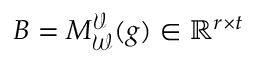<formula> <loc_0><loc_0><loc_500><loc_500>B = M _ { \mathcal { W } } ^ { \mathcal { V } } ( g ) \in \mathbb { R } ^ { r \times t }</formula> 